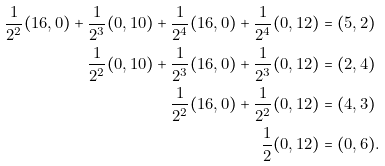<formula> <loc_0><loc_0><loc_500><loc_500>\frac { 1 } { 2 ^ { 2 } } ( 1 6 , 0 ) + \frac { 1 } { 2 ^ { 3 } } ( 0 , 1 0 ) + \frac { 1 } { 2 ^ { 4 } } ( 1 6 , 0 ) + \frac { 1 } { 2 ^ { 4 } } ( 0 , 1 2 ) & = ( 5 , 2 ) \\ \frac { 1 } { 2 ^ { 2 } } ( 0 , 1 0 ) + \frac { 1 } { 2 ^ { 3 } } ( 1 6 , 0 ) + \frac { 1 } { 2 ^ { 3 } } ( 0 , 1 2 ) & = ( 2 , 4 ) \\ \frac { 1 } { 2 ^ { 2 } } ( 1 6 , 0 ) + \frac { 1 } { 2 ^ { 2 } } ( 0 , 1 2 ) & = ( 4 , 3 ) \\ \frac { 1 } { 2 } ( 0 , 1 2 ) & = ( 0 , 6 ) .</formula> 